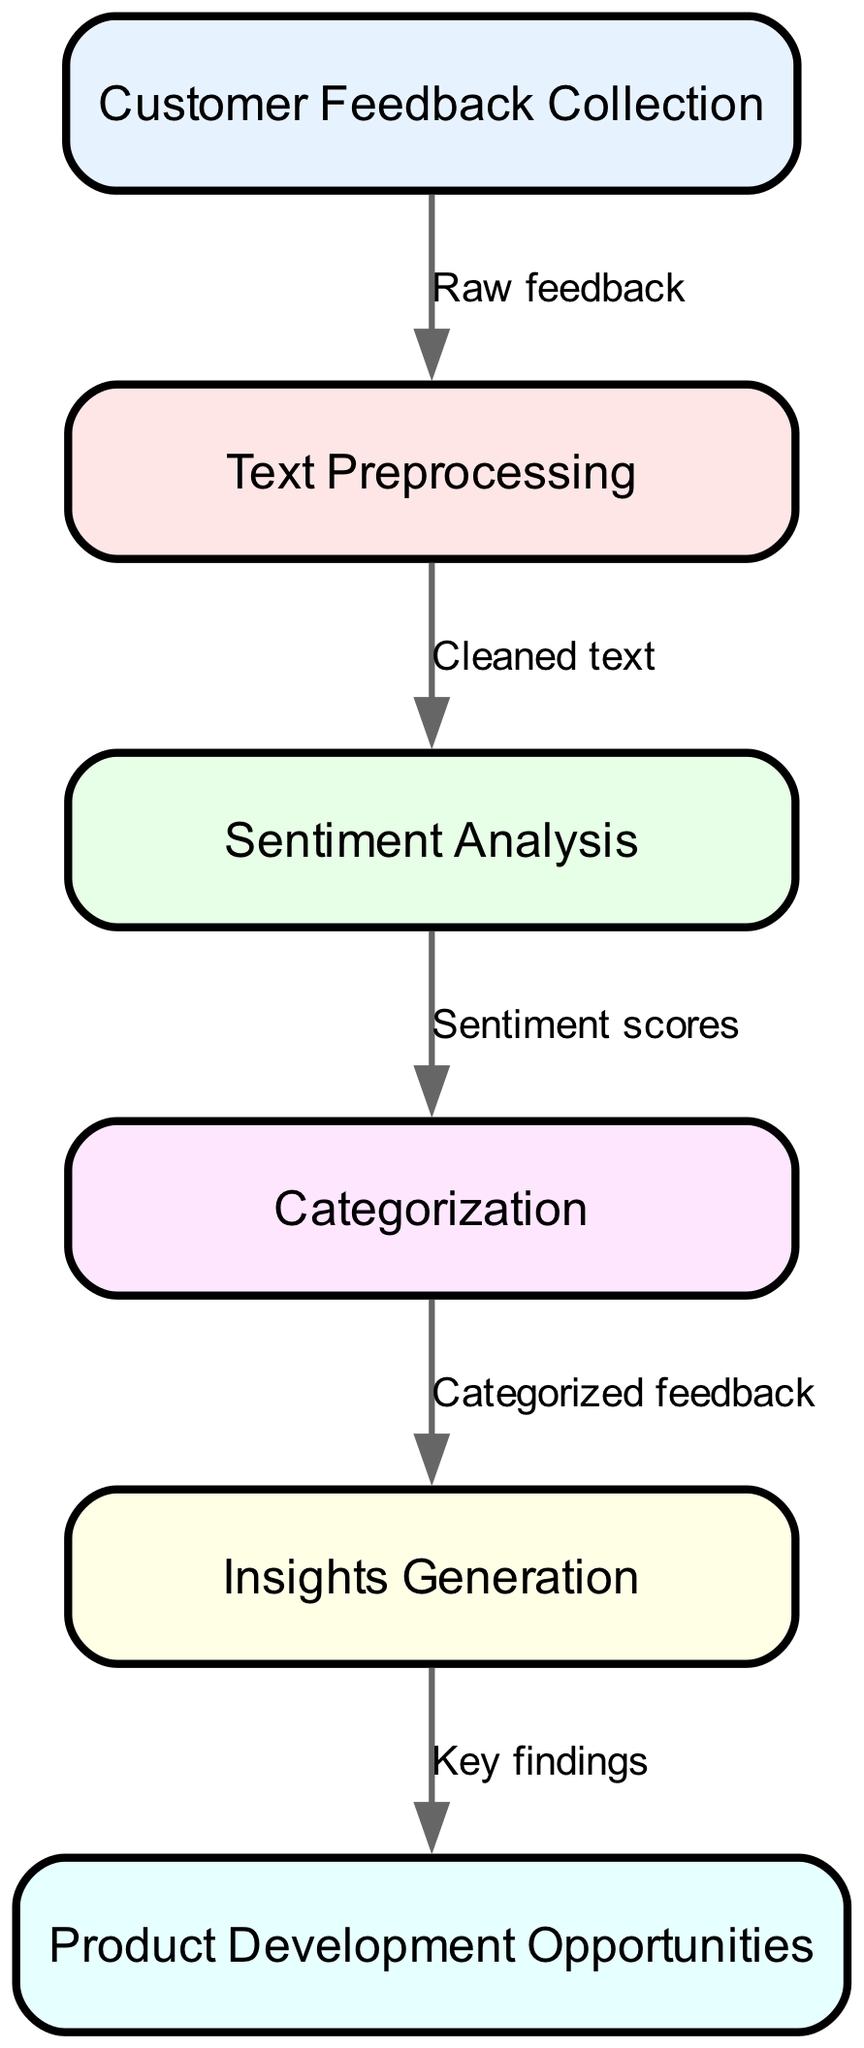What is the first step in the feedback analysis process? The first step in the diagram is labeled "Customer Feedback Collection," which indicates that the process begins with collecting feedback from customers.
Answer: Customer Feedback Collection How many nodes are there in the diagram? By counting the distinct labeled boxes in the diagram, I can identify a total of six nodes present in the framework.
Answer: 6 What type of data is transferred from "Text Preprocessing" to "Sentiment Analysis"? The edge connecting "Text Preprocessing" and "Sentiment Analysis" is labeled "Cleaned text," indicating that this type of data is being transferred.
Answer: Cleaned text What is the output of the "Sentiment Analysis" node? The arrow leading from "Sentiment Analysis" to "Categorization" is labeled "Sentiment scores," which represents the output produced by this node.
Answer: Sentiment scores How does "Insights Generation" relate to "Product Development Opportunities"? The connection from "Insights Generation" to "Product Development Opportunities" is labeled "Key findings," suggesting that insights derived from previous steps contribute to identifying potential product development opportunities.
Answer: Key findings Which node corresponds to the final outcome of the process? In the diagram, the last node depicted is "Product Development Opportunities," indicating that this represents the final result of the feedback analysis flow.
Answer: Product Development Opportunities What comes after "Categorization" in the flow? "Insights Generation" is the node that follows "Categorization," as shown by the directed edge connecting these two nodes.
Answer: Insights Generation Is there any node that collects customer feedback? The diagram clearly labels the first node as "Customer Feedback Collection," which is where customer feedback is initially gathered in the process.
Answer: Customer Feedback Collection 